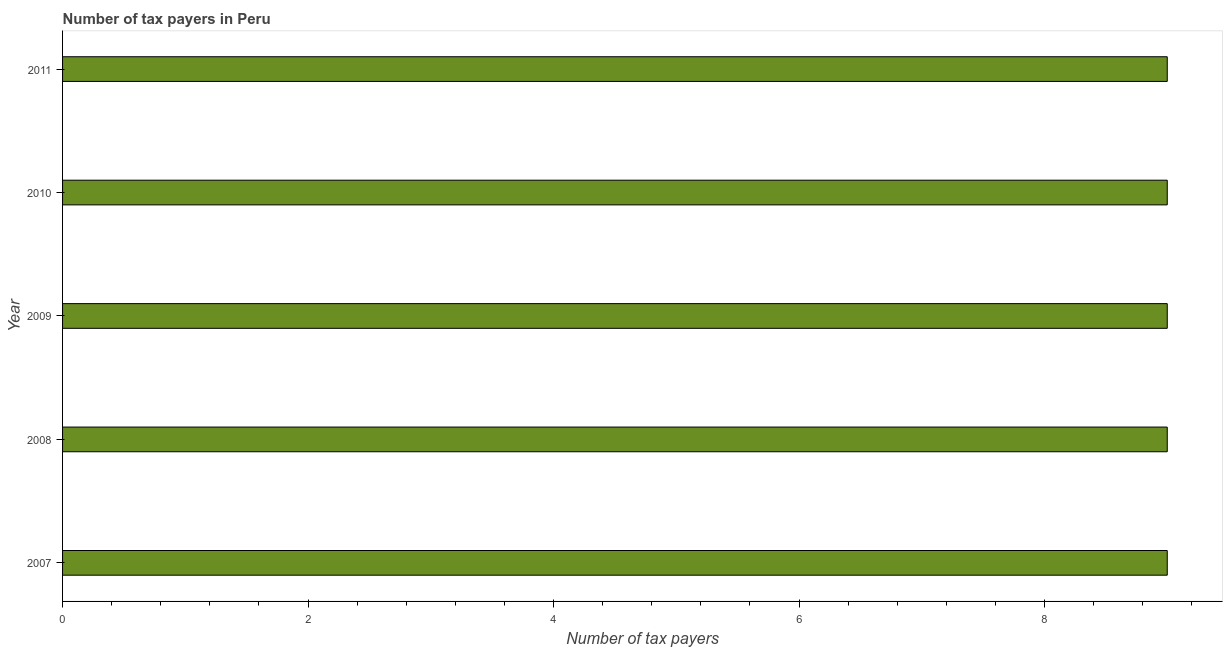Does the graph contain any zero values?
Provide a succinct answer. No. What is the title of the graph?
Your answer should be compact. Number of tax payers in Peru. What is the label or title of the X-axis?
Your answer should be very brief. Number of tax payers. What is the label or title of the Y-axis?
Your response must be concise. Year. Across all years, what is the minimum number of tax payers?
Give a very brief answer. 9. What is the sum of the number of tax payers?
Ensure brevity in your answer.  45. What is the difference between the number of tax payers in 2009 and 2011?
Your response must be concise. 0. In how many years, is the number of tax payers greater than 1.2 ?
Keep it short and to the point. 5. Is the sum of the number of tax payers in 2008 and 2009 greater than the maximum number of tax payers across all years?
Ensure brevity in your answer.  Yes. How many bars are there?
Provide a succinct answer. 5. Are the values on the major ticks of X-axis written in scientific E-notation?
Your answer should be very brief. No. What is the Number of tax payers of 2011?
Make the answer very short. 9. What is the difference between the Number of tax payers in 2007 and 2009?
Make the answer very short. 0. What is the difference between the Number of tax payers in 2007 and 2010?
Keep it short and to the point. 0. What is the difference between the Number of tax payers in 2007 and 2011?
Provide a short and direct response. 0. What is the difference between the Number of tax payers in 2008 and 2009?
Your response must be concise. 0. What is the difference between the Number of tax payers in 2008 and 2011?
Make the answer very short. 0. What is the difference between the Number of tax payers in 2009 and 2010?
Your response must be concise. 0. What is the ratio of the Number of tax payers in 2007 to that in 2009?
Provide a short and direct response. 1. What is the ratio of the Number of tax payers in 2007 to that in 2010?
Your answer should be compact. 1. What is the ratio of the Number of tax payers in 2007 to that in 2011?
Your answer should be very brief. 1. What is the ratio of the Number of tax payers in 2008 to that in 2010?
Provide a short and direct response. 1. What is the ratio of the Number of tax payers in 2009 to that in 2011?
Offer a very short reply. 1. What is the ratio of the Number of tax payers in 2010 to that in 2011?
Provide a short and direct response. 1. 